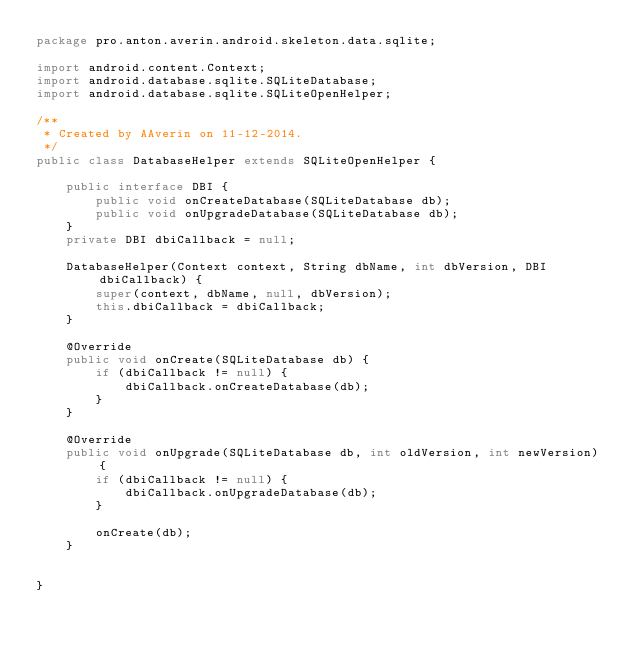Convert code to text. <code><loc_0><loc_0><loc_500><loc_500><_Java_>package pro.anton.averin.android.skeleton.data.sqlite;

import android.content.Context;
import android.database.sqlite.SQLiteDatabase;
import android.database.sqlite.SQLiteOpenHelper;

/**
 * Created by AAverin on 11-12-2014.
 */
public class DatabaseHelper extends SQLiteOpenHelper {

    public interface DBI {
        public void onCreateDatabase(SQLiteDatabase db);
        public void onUpgradeDatabase(SQLiteDatabase db);
    }
    private DBI dbiCallback = null;

    DatabaseHelper(Context context, String dbName, int dbVersion, DBI dbiCallback) {
        super(context, dbName, null, dbVersion);
        this.dbiCallback = dbiCallback;
    }

    @Override
    public void onCreate(SQLiteDatabase db) {
        if (dbiCallback != null) {
            dbiCallback.onCreateDatabase(db);
        }
    }

    @Override
    public void onUpgrade(SQLiteDatabase db, int oldVersion, int newVersion) {
        if (dbiCallback != null) {
            dbiCallback.onUpgradeDatabase(db);
        }

        onCreate(db);
    }


}</code> 